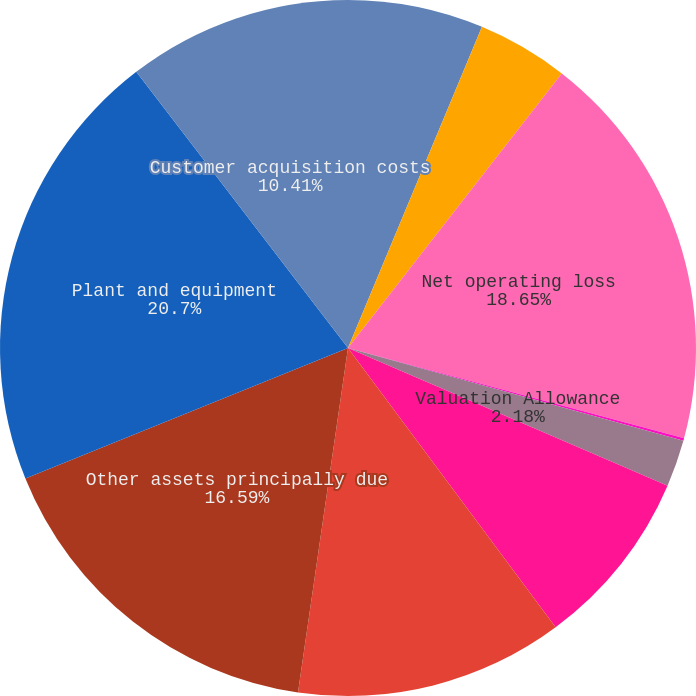Convert chart. <chart><loc_0><loc_0><loc_500><loc_500><pie_chart><fcel>Accrued liabilities<fcel>Deferred rent<fcel>Net operating loss<fcel>AMT credit<fcel>Valuation Allowance<fcel>Unrealized loss on hedging<fcel>Other<fcel>Other assets principally due<fcel>Plant and equipment<fcel>Customer acquisition costs<nl><fcel>6.29%<fcel>4.24%<fcel>18.65%<fcel>0.12%<fcel>2.18%<fcel>8.35%<fcel>12.47%<fcel>16.59%<fcel>20.71%<fcel>10.41%<nl></chart> 